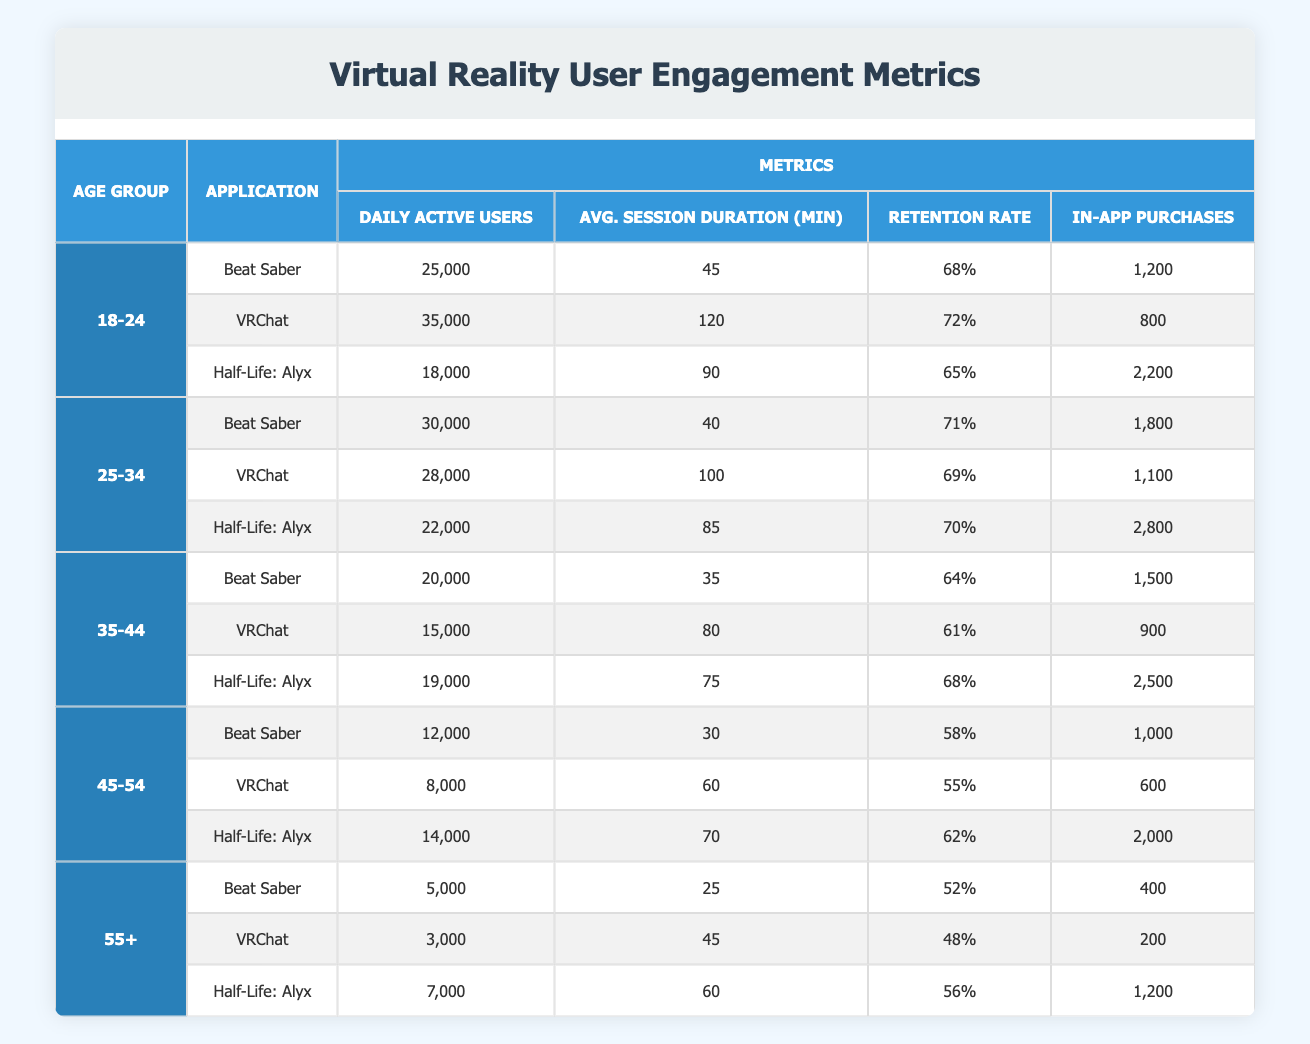What is the maximum daily active users for the application VRChat? Looking at the VRChat rows in the table, the maximum daily active users for any age group is 35,000, which occurs in the 18-24 age group.
Answer: 35,000 What is the average session duration of the application Half-Life: Alyx for the age group 25-34? In the table, the average session duration for Half-Life: Alyx in the 25-34 age group is 85 minutes.
Answer: 85 Is the retention rate for users aged 45-54 higher in Half-Life: Alyx or Beat Saber? For the age group 45-54, the retention rate for Half-Life: Alyx is 62% and for Beat Saber is 58%. Since 62% is greater than 58%, the retention rate is higher for Half-Life: Alyx.
Answer: Yes What is the total number of in-app purchases made by users aged 55+ across all applications? Summing the in-app purchases for the age group 55+ gives us: 400 + 200 + 1200 = 1800.
Answer: 1800 Which application has the lowest daily active users in the 35-44 age group? In the 35-44 age group, the applications have the following daily active users: Beat Saber (20,000), VRChat (15,000), and Half-Life: Alyx (19,000). The lowest number is for VRChat with 15,000.
Answer: VRChat What is the difference in average session duration between the applications Beat Saber and VRChat for users aged 25-34? For users aged 25-34, Beat Saber has an average session duration of 40 minutes and VRChat has 100 minutes. The difference is 100 - 40 = 60 minutes.
Answer: 60 Do users aged 18-24 have a higher retention rate in Beat Saber or Half-Life: Alyx? For users aged 18-24, Beat Saber has a retention rate of 68% and Half-Life: Alyx has 65%. Since 68% is greater than 65%, users aged 18-24 have a higher retention rate in Beat Saber.
Answer: Yes What is the average number of daily active users for the application Beat Saber across all age groups? For Beat Saber, the daily active users across the age groups are: 25,000 (18-24) + 30,000 (25-34) + 20,000 (35-44) + 12,000 (45-54) + 5,000 (55+) = 92,000. Dividing by the number of age groups (5), the average is 92,000 / 5 = 18,400.
Answer: 18,400 